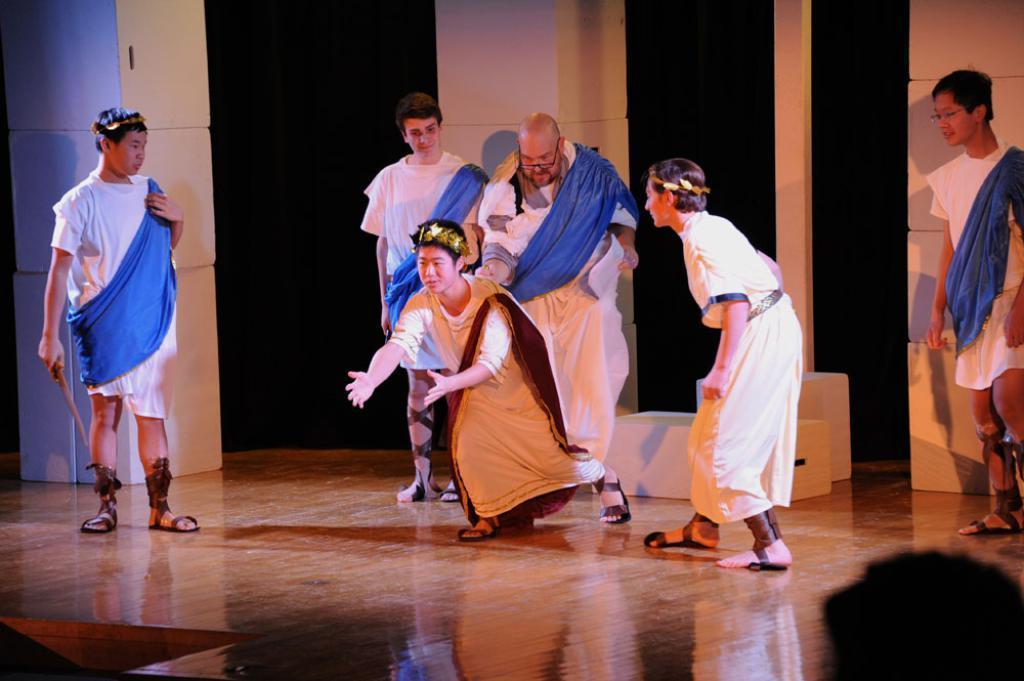Can you describe this image briefly? In this image I can see few people are standing on the floor. These people are wearing the white and blue color dresses. I can see one person with white and brown color dress. In the back I can see the white and black color wall. 